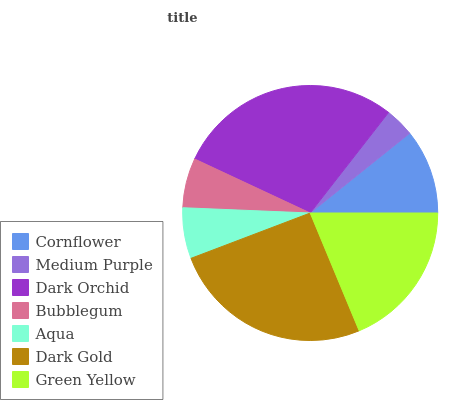Is Medium Purple the minimum?
Answer yes or no. Yes. Is Dark Orchid the maximum?
Answer yes or no. Yes. Is Dark Orchid the minimum?
Answer yes or no. No. Is Medium Purple the maximum?
Answer yes or no. No. Is Dark Orchid greater than Medium Purple?
Answer yes or no. Yes. Is Medium Purple less than Dark Orchid?
Answer yes or no. Yes. Is Medium Purple greater than Dark Orchid?
Answer yes or no. No. Is Dark Orchid less than Medium Purple?
Answer yes or no. No. Is Cornflower the high median?
Answer yes or no. Yes. Is Cornflower the low median?
Answer yes or no. Yes. Is Green Yellow the high median?
Answer yes or no. No. Is Bubblegum the low median?
Answer yes or no. No. 